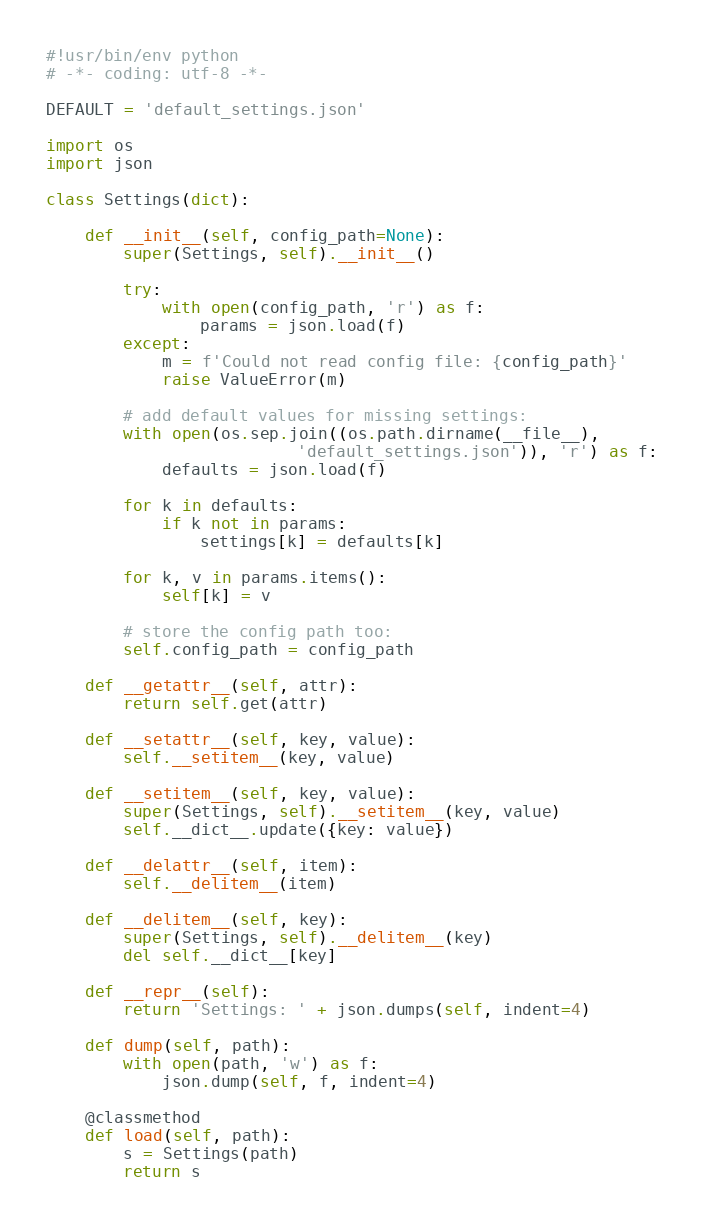<code> <loc_0><loc_0><loc_500><loc_500><_Python_>#!usr/bin/env python
# -*- coding: utf-8 -*-

DEFAULT = 'default_settings.json'

import os
import json

class Settings(dict):

    def __init__(self, config_path=None):
        super(Settings, self).__init__()

        try:
            with open(config_path, 'r') as f:
                params = json.load(f)
        except:
            m = f'Could not read config file: {config_path}'
            raise ValueError(m)

        # add default values for missing settings:
        with open(os.sep.join((os.path.dirname(__file__),
                          'default_settings.json')), 'r') as f:
            defaults = json.load(f)

        for k in defaults:
            if k not in params:
                settings[k] = defaults[k]

        for k, v in params.items():
            self[k] = v

        # store the config path too:
        self.config_path = config_path

    def __getattr__(self, attr):
        return self.get(attr)

    def __setattr__(self, key, value):
        self.__setitem__(key, value)

    def __setitem__(self, key, value):
        super(Settings, self).__setitem__(key, value)
        self.__dict__.update({key: value})

    def __delattr__(self, item):
        self.__delitem__(item)

    def __delitem__(self, key):
        super(Settings, self).__delitem__(key)
        del self.__dict__[key]

    def __repr__(self):
        return 'Settings: ' + json.dumps(self, indent=4)

    def dump(self, path):
        with open(path, 'w') as f:
            json.dump(self, f, indent=4)

    @classmethod
    def load(self, path):
        s = Settings(path)
        return s

</code> 